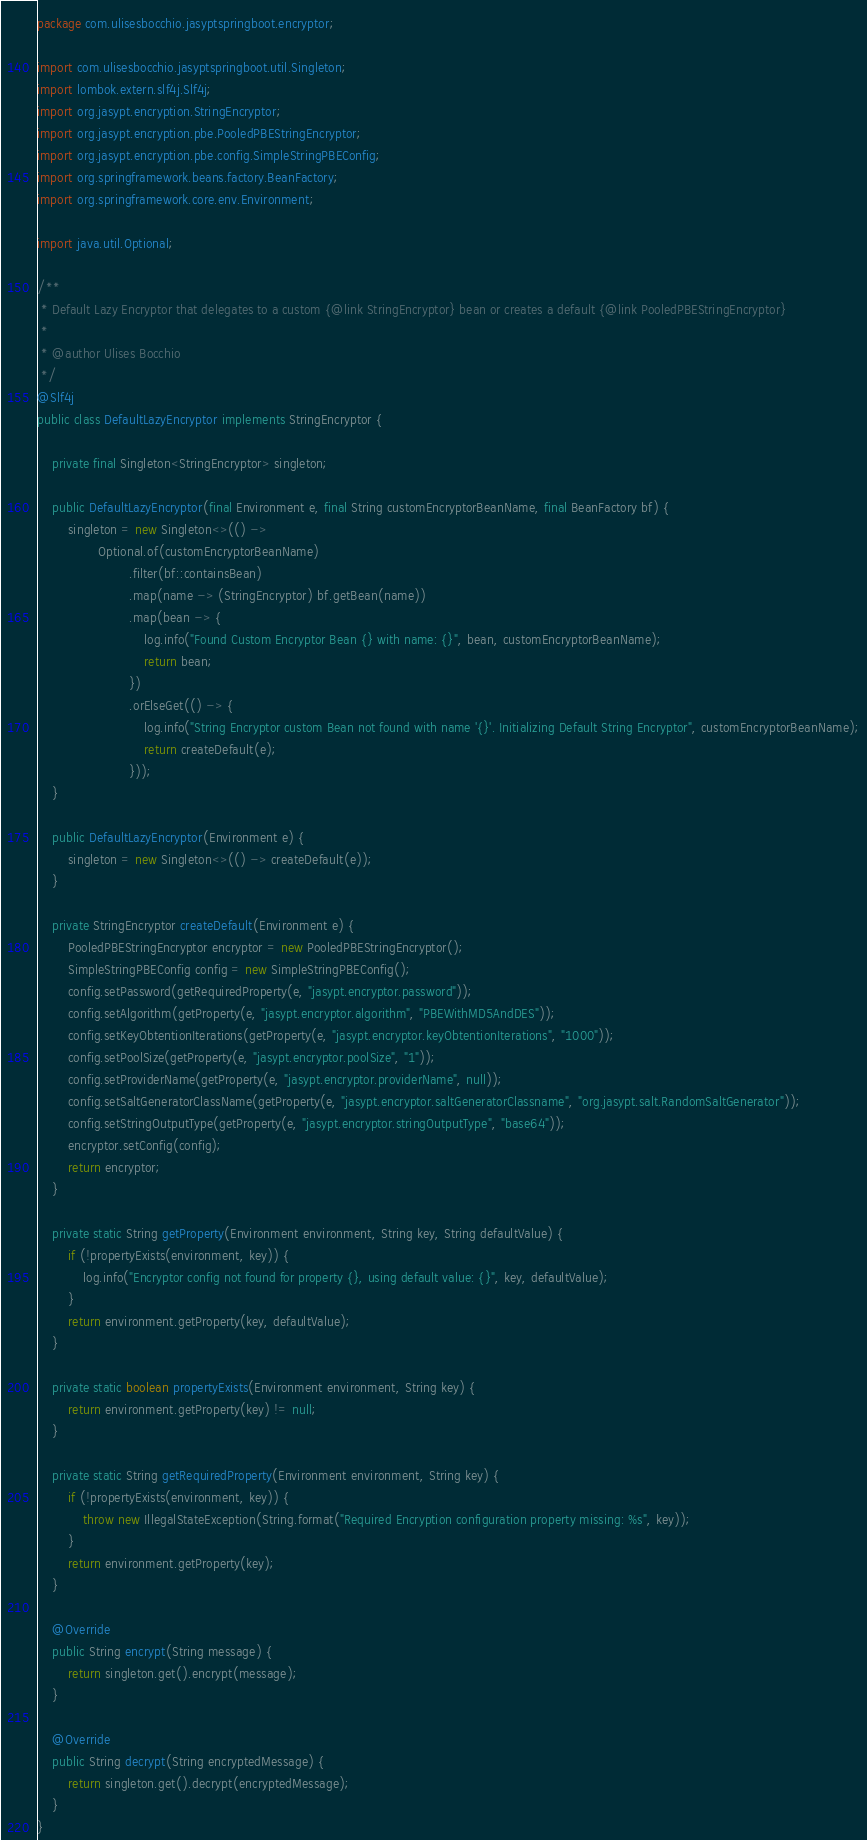Convert code to text. <code><loc_0><loc_0><loc_500><loc_500><_Java_>package com.ulisesbocchio.jasyptspringboot.encryptor;

import com.ulisesbocchio.jasyptspringboot.util.Singleton;
import lombok.extern.slf4j.Slf4j;
import org.jasypt.encryption.StringEncryptor;
import org.jasypt.encryption.pbe.PooledPBEStringEncryptor;
import org.jasypt.encryption.pbe.config.SimpleStringPBEConfig;
import org.springframework.beans.factory.BeanFactory;
import org.springframework.core.env.Environment;

import java.util.Optional;

/**
 * Default Lazy Encryptor that delegates to a custom {@link StringEncryptor} bean or creates a default {@link PooledPBEStringEncryptor}
 *
 * @author Ulises Bocchio
 */
@Slf4j
public class DefaultLazyEncryptor implements StringEncryptor {

    private final Singleton<StringEncryptor> singleton;

    public DefaultLazyEncryptor(final Environment e, final String customEncryptorBeanName, final BeanFactory bf) {
        singleton = new Singleton<>(() ->
                Optional.of(customEncryptorBeanName)
                        .filter(bf::containsBean)
                        .map(name -> (StringEncryptor) bf.getBean(name))
                        .map(bean -> {
                            log.info("Found Custom Encryptor Bean {} with name: {}", bean, customEncryptorBeanName);
                            return bean;
                        })
                        .orElseGet(() -> {
                            log.info("String Encryptor custom Bean not found with name '{}'. Initializing Default String Encryptor", customEncryptorBeanName);
                            return createDefault(e);
                        }));
    }

    public DefaultLazyEncryptor(Environment e) {
        singleton = new Singleton<>(() -> createDefault(e));
    }

    private StringEncryptor createDefault(Environment e) {
        PooledPBEStringEncryptor encryptor = new PooledPBEStringEncryptor();
        SimpleStringPBEConfig config = new SimpleStringPBEConfig();
        config.setPassword(getRequiredProperty(e, "jasypt.encryptor.password"));
        config.setAlgorithm(getProperty(e, "jasypt.encryptor.algorithm", "PBEWithMD5AndDES"));
        config.setKeyObtentionIterations(getProperty(e, "jasypt.encryptor.keyObtentionIterations", "1000"));
        config.setPoolSize(getProperty(e, "jasypt.encryptor.poolSize", "1"));
        config.setProviderName(getProperty(e, "jasypt.encryptor.providerName", null));
        config.setSaltGeneratorClassName(getProperty(e, "jasypt.encryptor.saltGeneratorClassname", "org.jasypt.salt.RandomSaltGenerator"));
        config.setStringOutputType(getProperty(e, "jasypt.encryptor.stringOutputType", "base64"));
        encryptor.setConfig(config);
        return encryptor;
    }

    private static String getProperty(Environment environment, String key, String defaultValue) {
        if (!propertyExists(environment, key)) {
            log.info("Encryptor config not found for property {}, using default value: {}", key, defaultValue);
        }
        return environment.getProperty(key, defaultValue);
    }

    private static boolean propertyExists(Environment environment, String key) {
        return environment.getProperty(key) != null;
    }

    private static String getRequiredProperty(Environment environment, String key) {
        if (!propertyExists(environment, key)) {
            throw new IllegalStateException(String.format("Required Encryption configuration property missing: %s", key));
        }
        return environment.getProperty(key);
    }

    @Override
    public String encrypt(String message) {
        return singleton.get().encrypt(message);
    }

    @Override
    public String decrypt(String encryptedMessage) {
        return singleton.get().decrypt(encryptedMessage);
    }
}
</code> 